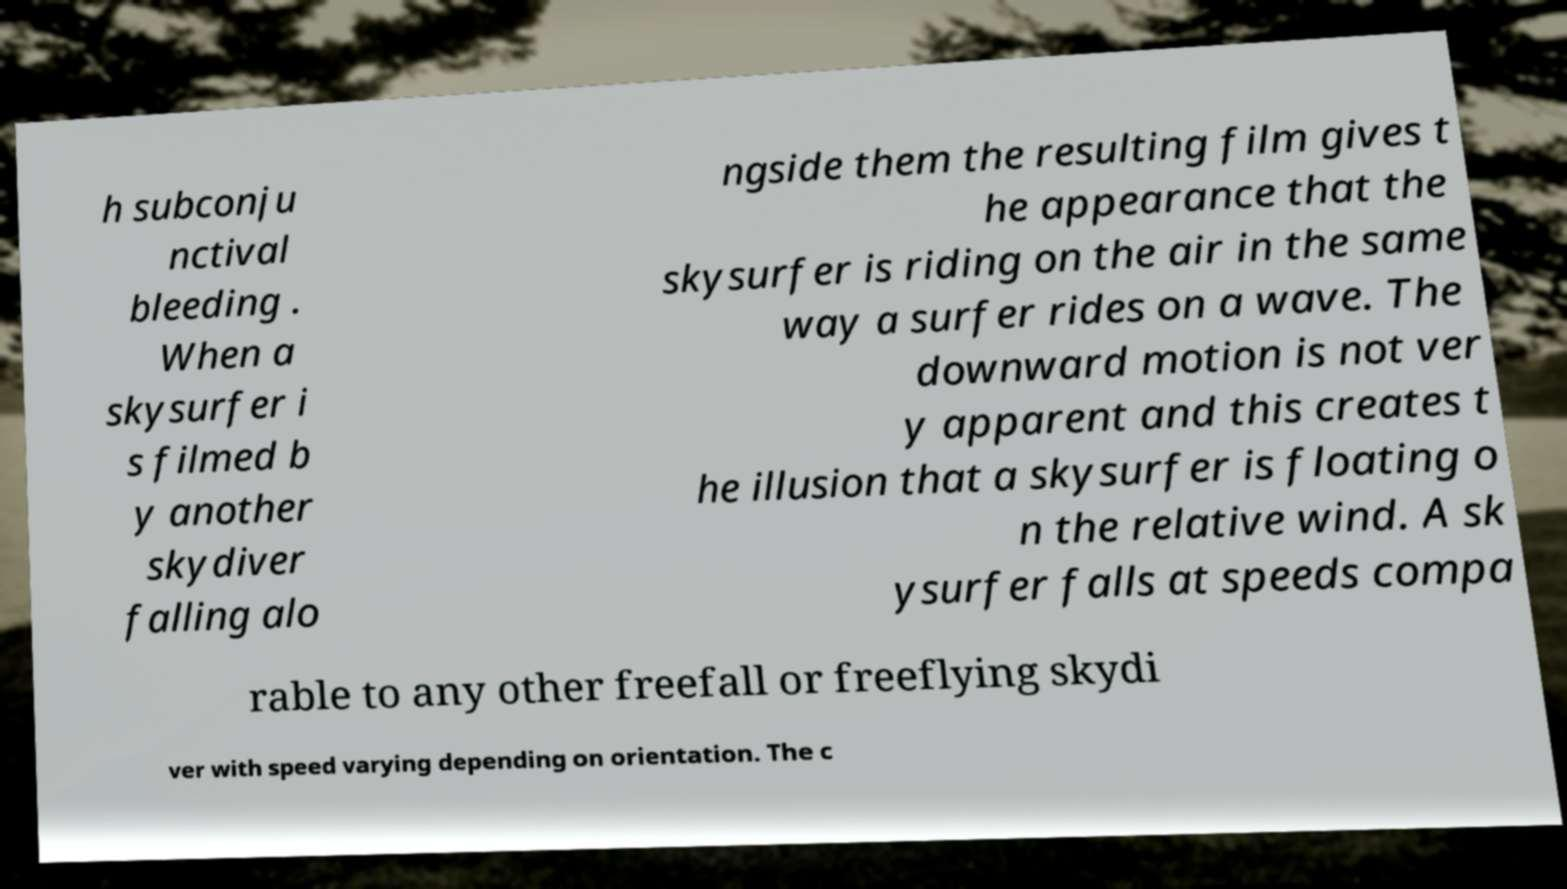What messages or text are displayed in this image? I need them in a readable, typed format. h subconju nctival bleeding . When a skysurfer i s filmed b y another skydiver falling alo ngside them the resulting film gives t he appearance that the skysurfer is riding on the air in the same way a surfer rides on a wave. The downward motion is not ver y apparent and this creates t he illusion that a skysurfer is floating o n the relative wind. A sk ysurfer falls at speeds compa rable to any other freefall or freeflying skydi ver with speed varying depending on orientation. The c 